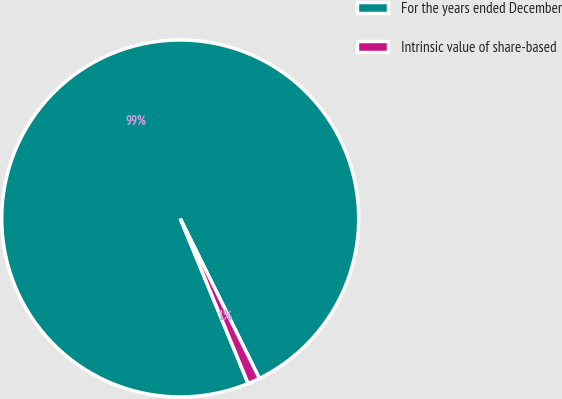Convert chart. <chart><loc_0><loc_0><loc_500><loc_500><pie_chart><fcel>For the years ended December<fcel>Intrinsic value of share-based<nl><fcel>98.9%<fcel>1.1%<nl></chart> 